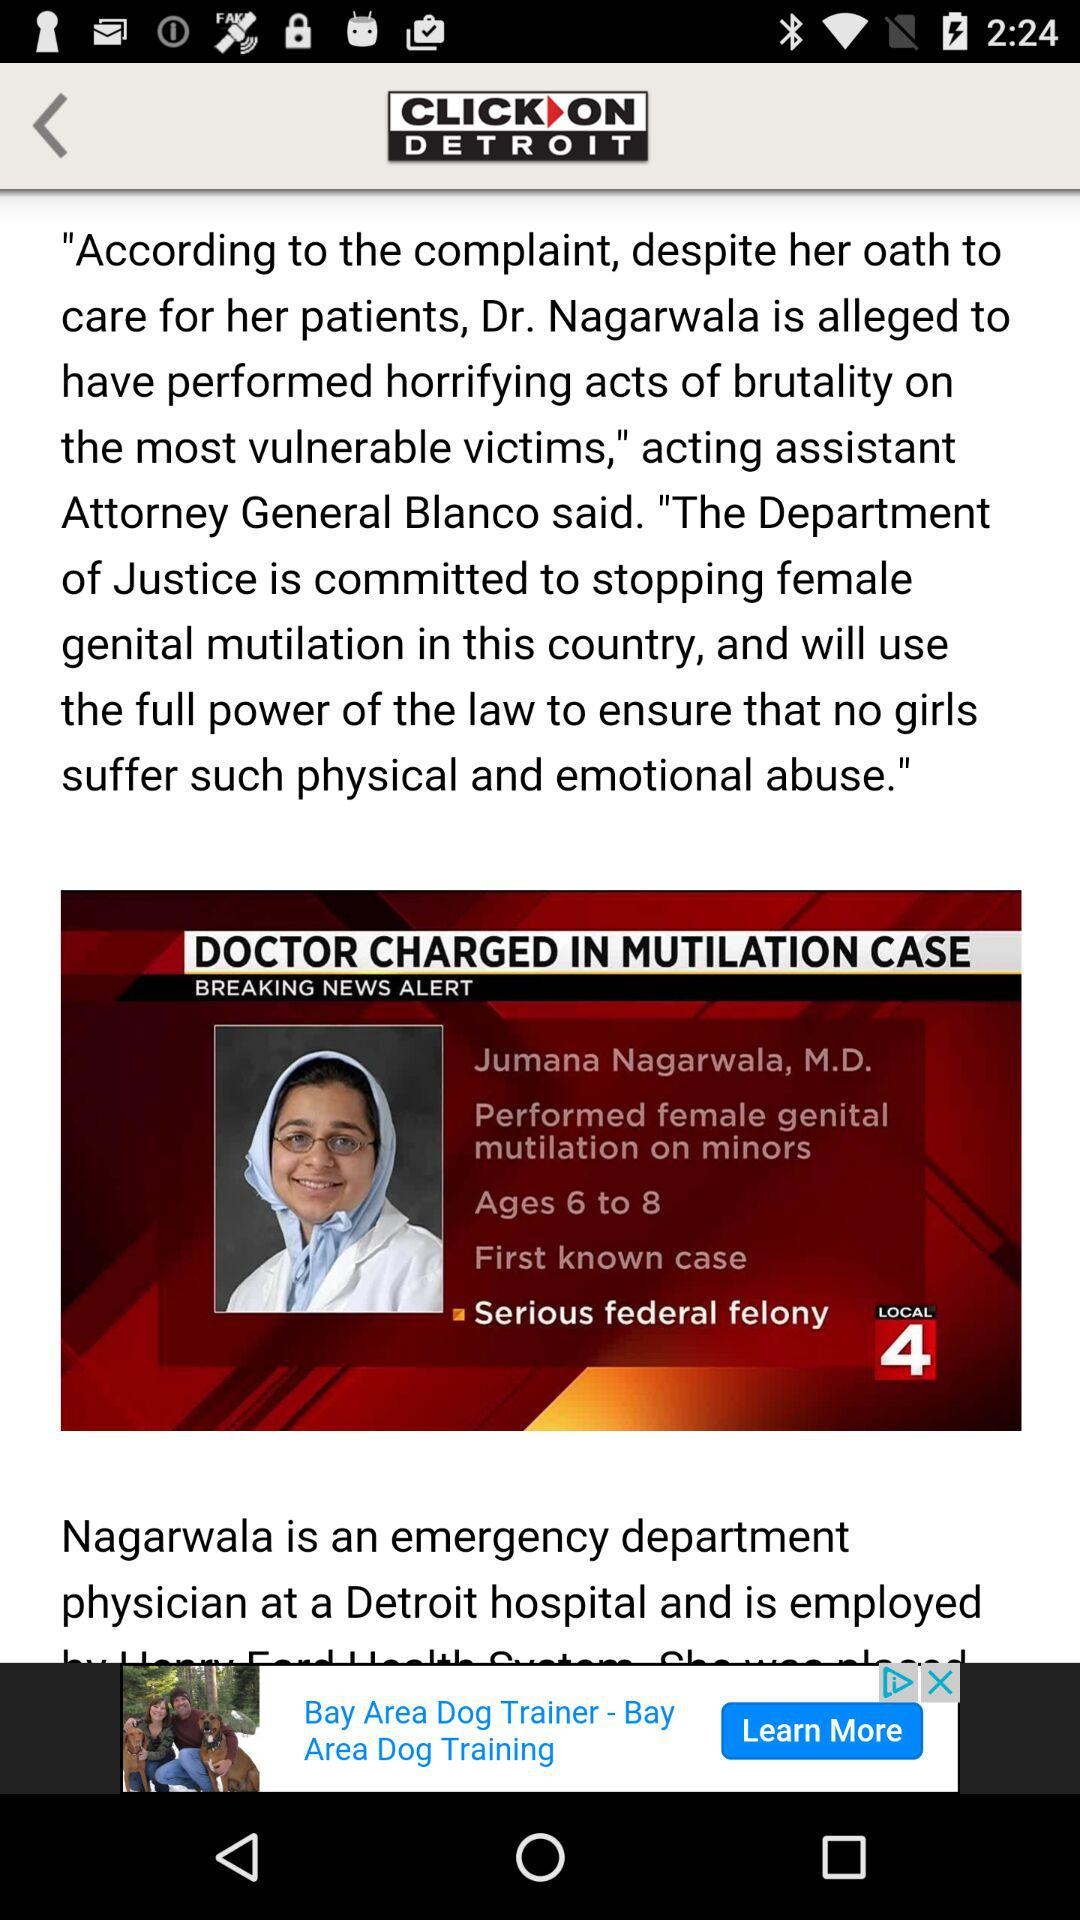Where is Nagarwala employed? Nagarwala is employed at a Detroit hospital. 